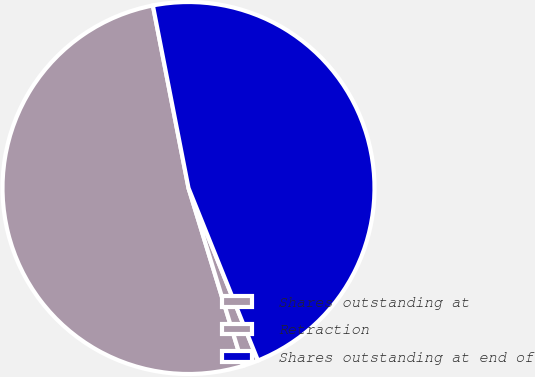Convert chart. <chart><loc_0><loc_0><loc_500><loc_500><pie_chart><fcel>Shares outstanding at<fcel>Retraction<fcel>Shares outstanding at end of<nl><fcel>51.68%<fcel>1.35%<fcel>46.98%<nl></chart> 